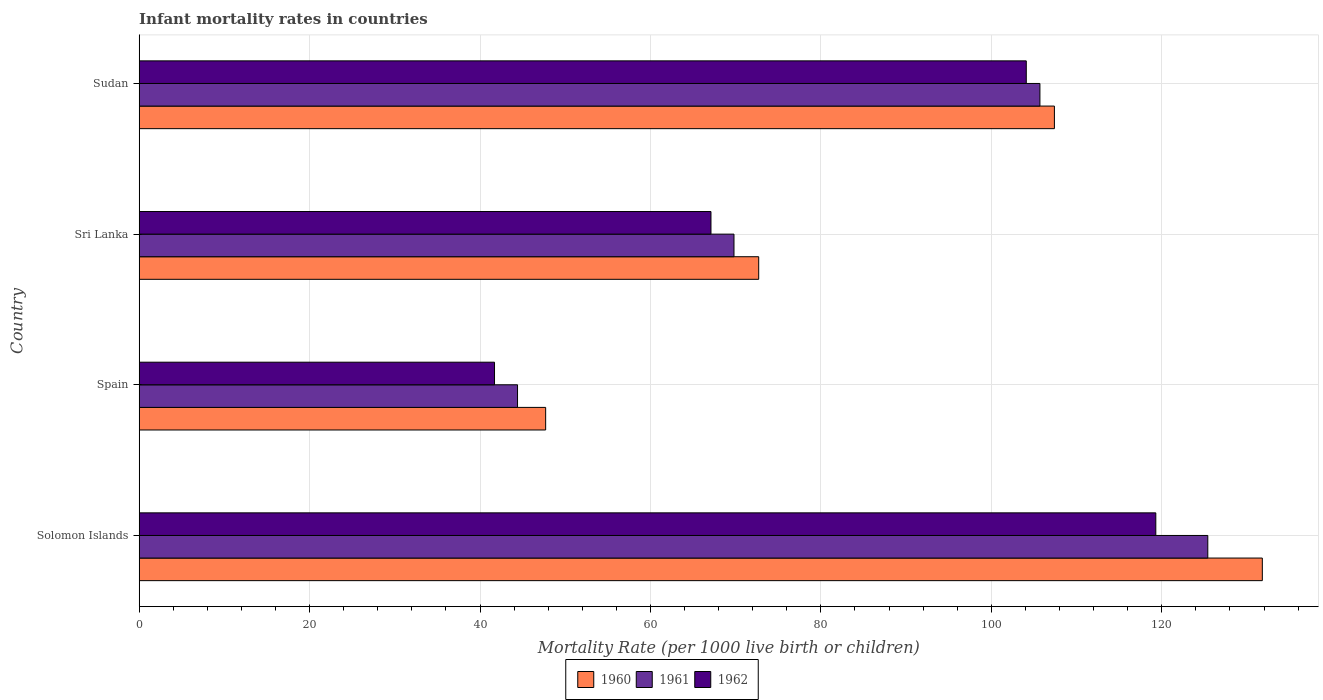How many different coloured bars are there?
Offer a terse response. 3. How many groups of bars are there?
Give a very brief answer. 4. Are the number of bars on each tick of the Y-axis equal?
Ensure brevity in your answer.  Yes. How many bars are there on the 1st tick from the bottom?
Your answer should be very brief. 3. What is the label of the 1st group of bars from the top?
Provide a short and direct response. Sudan. In how many cases, is the number of bars for a given country not equal to the number of legend labels?
Ensure brevity in your answer.  0. What is the infant mortality rate in 1962 in Sudan?
Keep it short and to the point. 104.1. Across all countries, what is the maximum infant mortality rate in 1962?
Make the answer very short. 119.3. Across all countries, what is the minimum infant mortality rate in 1960?
Your answer should be very brief. 47.7. In which country was the infant mortality rate in 1961 maximum?
Give a very brief answer. Solomon Islands. What is the total infant mortality rate in 1960 in the graph?
Ensure brevity in your answer.  359.6. What is the difference between the infant mortality rate in 1961 in Spain and that in Sri Lanka?
Provide a short and direct response. -25.4. What is the difference between the infant mortality rate in 1962 in Sudan and the infant mortality rate in 1960 in Solomon Islands?
Provide a succinct answer. -27.7. What is the average infant mortality rate in 1961 per country?
Provide a succinct answer. 86.33. What is the difference between the infant mortality rate in 1960 and infant mortality rate in 1961 in Sri Lanka?
Offer a terse response. 2.9. In how many countries, is the infant mortality rate in 1961 greater than 28 ?
Provide a succinct answer. 4. What is the ratio of the infant mortality rate in 1960 in Sri Lanka to that in Sudan?
Keep it short and to the point. 0.68. Is the infant mortality rate in 1961 in Spain less than that in Sri Lanka?
Provide a succinct answer. Yes. Is the difference between the infant mortality rate in 1960 in Solomon Islands and Spain greater than the difference between the infant mortality rate in 1961 in Solomon Islands and Spain?
Make the answer very short. Yes. What is the difference between the highest and the second highest infant mortality rate in 1961?
Your answer should be compact. 19.7. What does the 3rd bar from the top in Sri Lanka represents?
Your answer should be very brief. 1960. What is the difference between two consecutive major ticks on the X-axis?
Ensure brevity in your answer.  20. Are the values on the major ticks of X-axis written in scientific E-notation?
Provide a succinct answer. No. Does the graph contain grids?
Make the answer very short. Yes. Where does the legend appear in the graph?
Offer a very short reply. Bottom center. How are the legend labels stacked?
Keep it short and to the point. Horizontal. What is the title of the graph?
Make the answer very short. Infant mortality rates in countries. Does "1988" appear as one of the legend labels in the graph?
Provide a short and direct response. No. What is the label or title of the X-axis?
Ensure brevity in your answer.  Mortality Rate (per 1000 live birth or children). What is the Mortality Rate (per 1000 live birth or children) in 1960 in Solomon Islands?
Offer a terse response. 131.8. What is the Mortality Rate (per 1000 live birth or children) in 1961 in Solomon Islands?
Give a very brief answer. 125.4. What is the Mortality Rate (per 1000 live birth or children) in 1962 in Solomon Islands?
Offer a very short reply. 119.3. What is the Mortality Rate (per 1000 live birth or children) of 1960 in Spain?
Make the answer very short. 47.7. What is the Mortality Rate (per 1000 live birth or children) in 1961 in Spain?
Give a very brief answer. 44.4. What is the Mortality Rate (per 1000 live birth or children) in 1962 in Spain?
Offer a terse response. 41.7. What is the Mortality Rate (per 1000 live birth or children) in 1960 in Sri Lanka?
Offer a terse response. 72.7. What is the Mortality Rate (per 1000 live birth or children) of 1961 in Sri Lanka?
Give a very brief answer. 69.8. What is the Mortality Rate (per 1000 live birth or children) in 1962 in Sri Lanka?
Your response must be concise. 67.1. What is the Mortality Rate (per 1000 live birth or children) in 1960 in Sudan?
Give a very brief answer. 107.4. What is the Mortality Rate (per 1000 live birth or children) in 1961 in Sudan?
Your answer should be compact. 105.7. What is the Mortality Rate (per 1000 live birth or children) in 1962 in Sudan?
Your response must be concise. 104.1. Across all countries, what is the maximum Mortality Rate (per 1000 live birth or children) of 1960?
Ensure brevity in your answer.  131.8. Across all countries, what is the maximum Mortality Rate (per 1000 live birth or children) in 1961?
Keep it short and to the point. 125.4. Across all countries, what is the maximum Mortality Rate (per 1000 live birth or children) of 1962?
Offer a terse response. 119.3. Across all countries, what is the minimum Mortality Rate (per 1000 live birth or children) in 1960?
Your response must be concise. 47.7. Across all countries, what is the minimum Mortality Rate (per 1000 live birth or children) of 1961?
Offer a very short reply. 44.4. Across all countries, what is the minimum Mortality Rate (per 1000 live birth or children) in 1962?
Make the answer very short. 41.7. What is the total Mortality Rate (per 1000 live birth or children) in 1960 in the graph?
Keep it short and to the point. 359.6. What is the total Mortality Rate (per 1000 live birth or children) in 1961 in the graph?
Your answer should be compact. 345.3. What is the total Mortality Rate (per 1000 live birth or children) of 1962 in the graph?
Offer a very short reply. 332.2. What is the difference between the Mortality Rate (per 1000 live birth or children) of 1960 in Solomon Islands and that in Spain?
Give a very brief answer. 84.1. What is the difference between the Mortality Rate (per 1000 live birth or children) of 1962 in Solomon Islands and that in Spain?
Offer a terse response. 77.6. What is the difference between the Mortality Rate (per 1000 live birth or children) of 1960 in Solomon Islands and that in Sri Lanka?
Give a very brief answer. 59.1. What is the difference between the Mortality Rate (per 1000 live birth or children) in 1961 in Solomon Islands and that in Sri Lanka?
Make the answer very short. 55.6. What is the difference between the Mortality Rate (per 1000 live birth or children) of 1962 in Solomon Islands and that in Sri Lanka?
Give a very brief answer. 52.2. What is the difference between the Mortality Rate (per 1000 live birth or children) of 1960 in Solomon Islands and that in Sudan?
Make the answer very short. 24.4. What is the difference between the Mortality Rate (per 1000 live birth or children) in 1960 in Spain and that in Sri Lanka?
Keep it short and to the point. -25. What is the difference between the Mortality Rate (per 1000 live birth or children) of 1961 in Spain and that in Sri Lanka?
Your response must be concise. -25.4. What is the difference between the Mortality Rate (per 1000 live birth or children) in 1962 in Spain and that in Sri Lanka?
Your answer should be very brief. -25.4. What is the difference between the Mortality Rate (per 1000 live birth or children) in 1960 in Spain and that in Sudan?
Ensure brevity in your answer.  -59.7. What is the difference between the Mortality Rate (per 1000 live birth or children) of 1961 in Spain and that in Sudan?
Make the answer very short. -61.3. What is the difference between the Mortality Rate (per 1000 live birth or children) in 1962 in Spain and that in Sudan?
Your response must be concise. -62.4. What is the difference between the Mortality Rate (per 1000 live birth or children) of 1960 in Sri Lanka and that in Sudan?
Give a very brief answer. -34.7. What is the difference between the Mortality Rate (per 1000 live birth or children) in 1961 in Sri Lanka and that in Sudan?
Make the answer very short. -35.9. What is the difference between the Mortality Rate (per 1000 live birth or children) of 1962 in Sri Lanka and that in Sudan?
Give a very brief answer. -37. What is the difference between the Mortality Rate (per 1000 live birth or children) of 1960 in Solomon Islands and the Mortality Rate (per 1000 live birth or children) of 1961 in Spain?
Provide a short and direct response. 87.4. What is the difference between the Mortality Rate (per 1000 live birth or children) in 1960 in Solomon Islands and the Mortality Rate (per 1000 live birth or children) in 1962 in Spain?
Offer a terse response. 90.1. What is the difference between the Mortality Rate (per 1000 live birth or children) in 1961 in Solomon Islands and the Mortality Rate (per 1000 live birth or children) in 1962 in Spain?
Ensure brevity in your answer.  83.7. What is the difference between the Mortality Rate (per 1000 live birth or children) of 1960 in Solomon Islands and the Mortality Rate (per 1000 live birth or children) of 1961 in Sri Lanka?
Provide a short and direct response. 62. What is the difference between the Mortality Rate (per 1000 live birth or children) of 1960 in Solomon Islands and the Mortality Rate (per 1000 live birth or children) of 1962 in Sri Lanka?
Your answer should be compact. 64.7. What is the difference between the Mortality Rate (per 1000 live birth or children) in 1961 in Solomon Islands and the Mortality Rate (per 1000 live birth or children) in 1962 in Sri Lanka?
Give a very brief answer. 58.3. What is the difference between the Mortality Rate (per 1000 live birth or children) in 1960 in Solomon Islands and the Mortality Rate (per 1000 live birth or children) in 1961 in Sudan?
Ensure brevity in your answer.  26.1. What is the difference between the Mortality Rate (per 1000 live birth or children) in 1960 in Solomon Islands and the Mortality Rate (per 1000 live birth or children) in 1962 in Sudan?
Your answer should be very brief. 27.7. What is the difference between the Mortality Rate (per 1000 live birth or children) in 1961 in Solomon Islands and the Mortality Rate (per 1000 live birth or children) in 1962 in Sudan?
Provide a short and direct response. 21.3. What is the difference between the Mortality Rate (per 1000 live birth or children) of 1960 in Spain and the Mortality Rate (per 1000 live birth or children) of 1961 in Sri Lanka?
Make the answer very short. -22.1. What is the difference between the Mortality Rate (per 1000 live birth or children) of 1960 in Spain and the Mortality Rate (per 1000 live birth or children) of 1962 in Sri Lanka?
Make the answer very short. -19.4. What is the difference between the Mortality Rate (per 1000 live birth or children) of 1961 in Spain and the Mortality Rate (per 1000 live birth or children) of 1962 in Sri Lanka?
Give a very brief answer. -22.7. What is the difference between the Mortality Rate (per 1000 live birth or children) of 1960 in Spain and the Mortality Rate (per 1000 live birth or children) of 1961 in Sudan?
Give a very brief answer. -58. What is the difference between the Mortality Rate (per 1000 live birth or children) in 1960 in Spain and the Mortality Rate (per 1000 live birth or children) in 1962 in Sudan?
Make the answer very short. -56.4. What is the difference between the Mortality Rate (per 1000 live birth or children) in 1961 in Spain and the Mortality Rate (per 1000 live birth or children) in 1962 in Sudan?
Make the answer very short. -59.7. What is the difference between the Mortality Rate (per 1000 live birth or children) in 1960 in Sri Lanka and the Mortality Rate (per 1000 live birth or children) in 1961 in Sudan?
Offer a terse response. -33. What is the difference between the Mortality Rate (per 1000 live birth or children) of 1960 in Sri Lanka and the Mortality Rate (per 1000 live birth or children) of 1962 in Sudan?
Your response must be concise. -31.4. What is the difference between the Mortality Rate (per 1000 live birth or children) in 1961 in Sri Lanka and the Mortality Rate (per 1000 live birth or children) in 1962 in Sudan?
Your response must be concise. -34.3. What is the average Mortality Rate (per 1000 live birth or children) in 1960 per country?
Your answer should be very brief. 89.9. What is the average Mortality Rate (per 1000 live birth or children) of 1961 per country?
Provide a short and direct response. 86.33. What is the average Mortality Rate (per 1000 live birth or children) of 1962 per country?
Your answer should be very brief. 83.05. What is the difference between the Mortality Rate (per 1000 live birth or children) of 1960 and Mortality Rate (per 1000 live birth or children) of 1961 in Solomon Islands?
Offer a terse response. 6.4. What is the difference between the Mortality Rate (per 1000 live birth or children) of 1960 and Mortality Rate (per 1000 live birth or children) of 1962 in Solomon Islands?
Offer a very short reply. 12.5. What is the difference between the Mortality Rate (per 1000 live birth or children) in 1961 and Mortality Rate (per 1000 live birth or children) in 1962 in Solomon Islands?
Your answer should be very brief. 6.1. What is the difference between the Mortality Rate (per 1000 live birth or children) in 1960 and Mortality Rate (per 1000 live birth or children) in 1962 in Spain?
Ensure brevity in your answer.  6. What is the difference between the Mortality Rate (per 1000 live birth or children) in 1961 and Mortality Rate (per 1000 live birth or children) in 1962 in Spain?
Provide a succinct answer. 2.7. What is the difference between the Mortality Rate (per 1000 live birth or children) of 1960 and Mortality Rate (per 1000 live birth or children) of 1961 in Sri Lanka?
Provide a short and direct response. 2.9. What is the difference between the Mortality Rate (per 1000 live birth or children) in 1961 and Mortality Rate (per 1000 live birth or children) in 1962 in Sri Lanka?
Offer a very short reply. 2.7. What is the difference between the Mortality Rate (per 1000 live birth or children) of 1960 and Mortality Rate (per 1000 live birth or children) of 1962 in Sudan?
Offer a very short reply. 3.3. What is the ratio of the Mortality Rate (per 1000 live birth or children) in 1960 in Solomon Islands to that in Spain?
Offer a very short reply. 2.76. What is the ratio of the Mortality Rate (per 1000 live birth or children) of 1961 in Solomon Islands to that in Spain?
Your response must be concise. 2.82. What is the ratio of the Mortality Rate (per 1000 live birth or children) of 1962 in Solomon Islands to that in Spain?
Your response must be concise. 2.86. What is the ratio of the Mortality Rate (per 1000 live birth or children) of 1960 in Solomon Islands to that in Sri Lanka?
Your answer should be very brief. 1.81. What is the ratio of the Mortality Rate (per 1000 live birth or children) in 1961 in Solomon Islands to that in Sri Lanka?
Provide a short and direct response. 1.8. What is the ratio of the Mortality Rate (per 1000 live birth or children) in 1962 in Solomon Islands to that in Sri Lanka?
Make the answer very short. 1.78. What is the ratio of the Mortality Rate (per 1000 live birth or children) in 1960 in Solomon Islands to that in Sudan?
Offer a terse response. 1.23. What is the ratio of the Mortality Rate (per 1000 live birth or children) in 1961 in Solomon Islands to that in Sudan?
Offer a terse response. 1.19. What is the ratio of the Mortality Rate (per 1000 live birth or children) in 1962 in Solomon Islands to that in Sudan?
Give a very brief answer. 1.15. What is the ratio of the Mortality Rate (per 1000 live birth or children) in 1960 in Spain to that in Sri Lanka?
Your answer should be compact. 0.66. What is the ratio of the Mortality Rate (per 1000 live birth or children) of 1961 in Spain to that in Sri Lanka?
Give a very brief answer. 0.64. What is the ratio of the Mortality Rate (per 1000 live birth or children) of 1962 in Spain to that in Sri Lanka?
Keep it short and to the point. 0.62. What is the ratio of the Mortality Rate (per 1000 live birth or children) of 1960 in Spain to that in Sudan?
Provide a short and direct response. 0.44. What is the ratio of the Mortality Rate (per 1000 live birth or children) in 1961 in Spain to that in Sudan?
Offer a very short reply. 0.42. What is the ratio of the Mortality Rate (per 1000 live birth or children) of 1962 in Spain to that in Sudan?
Keep it short and to the point. 0.4. What is the ratio of the Mortality Rate (per 1000 live birth or children) of 1960 in Sri Lanka to that in Sudan?
Your answer should be compact. 0.68. What is the ratio of the Mortality Rate (per 1000 live birth or children) in 1961 in Sri Lanka to that in Sudan?
Keep it short and to the point. 0.66. What is the ratio of the Mortality Rate (per 1000 live birth or children) in 1962 in Sri Lanka to that in Sudan?
Your response must be concise. 0.64. What is the difference between the highest and the second highest Mortality Rate (per 1000 live birth or children) in 1960?
Keep it short and to the point. 24.4. What is the difference between the highest and the second highest Mortality Rate (per 1000 live birth or children) of 1962?
Your answer should be very brief. 15.2. What is the difference between the highest and the lowest Mortality Rate (per 1000 live birth or children) in 1960?
Offer a terse response. 84.1. What is the difference between the highest and the lowest Mortality Rate (per 1000 live birth or children) in 1962?
Ensure brevity in your answer.  77.6. 